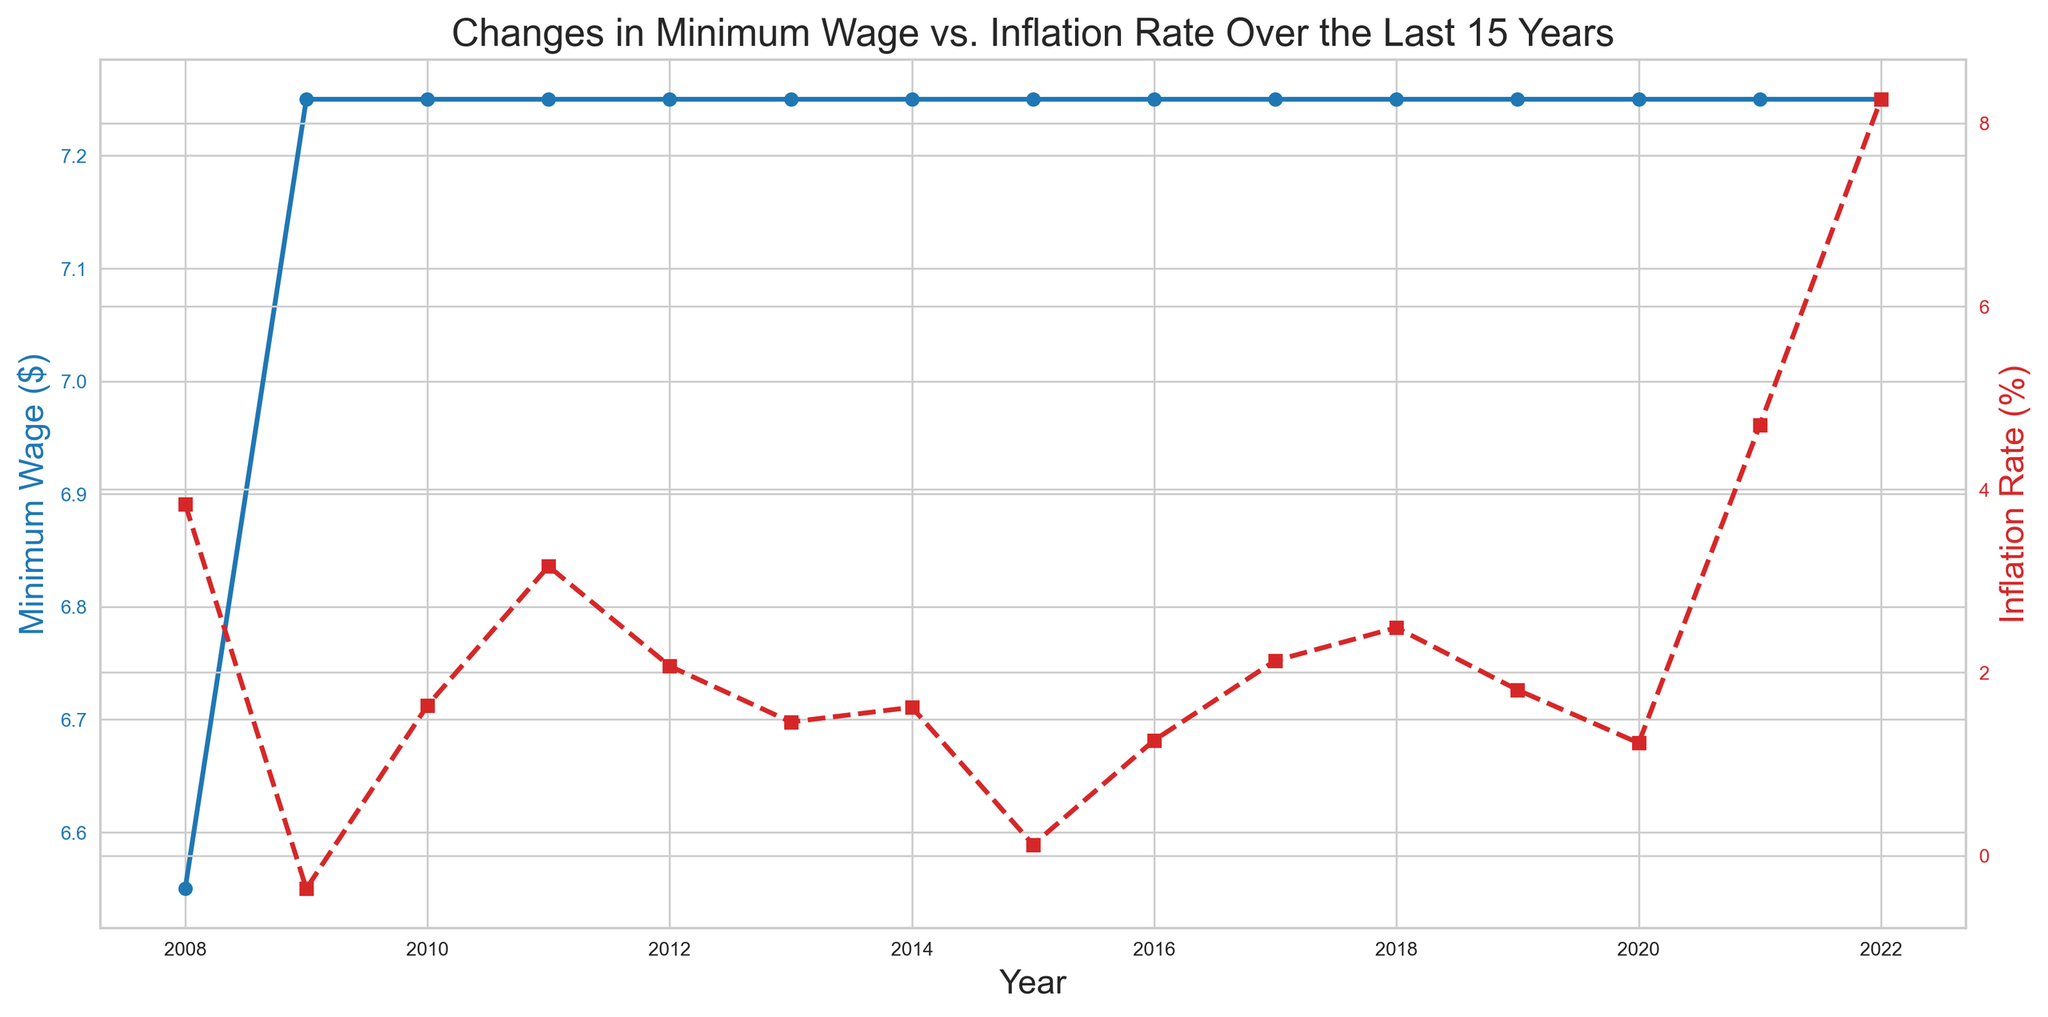What's the trend in minimum wage over the last 15 years? The minimum wage remains constant at $7.25 from 2009 to 2022 after seeing an increase from $6.55 in 2008.
Answer: Constant from 2009 onwards What is the maximum inflation rate observed in the last 15 years? By examining the red line for inflation rate, the highest point is reached in 2022 with a value of 8.26%.
Answer: 8.26% Which year had the highest inflation rate, and what was the minimum wage that year? The highest inflation rate was in 2022 at 8.26%, and the minimum wage that year was $7.25.
Answer: 2022, $7.25 In which years did the inflation rate drop compared to the previous year? The inflation rate drops in the following years: 2009 compared to 2008, 2010 compared to 2009, 2013 compared to 2012, 2014 compared to 2011, 2015 compared to 2014, 2017 compared to 2016, and 2020 compared to 2019.
Answer: 2009, 2010, 2013, 2014, 2015, 2017, 2020 In which year was the inflation rate negative, and what was its value? Observing the red line, the inflation rate became negative in 2009 with a value of -0.36%.
Answer: 2009, -0.36% What is the difference in inflation rates between 2021 and 2022? The inflation rate in 2021 is 4.70% and in 2022 is 8.26%. The difference is 8.26 - 4.70 = 3.56%.
Answer: 3.56% How many years saw an inflation rate above 4%? The years with an inflation rate above 4% are 2008, 2021, and 2022.
Answer: 3 years What color represents the minimum wage on the plot, and what is the marker style used? The minimum wage is represented by a blue line with circular markers.
Answer: Blue, circular Compare the inflation rates of 2010 and 2011. Which year had a higher rate? The inflation rate in 2010 was 1.64%, while in 2011 it was 3.16%. 2011 had a higher rate.
Answer: 2011 What's the average minimum wage over the 15 years? The minimum wage was $6.55 in 2008 then increased to $7.25 from 2009 onwards. Calculating the average: (6.55 + 7.25*14)/15 = 108.05/15 = 7.2033.
Answer: $7.20 